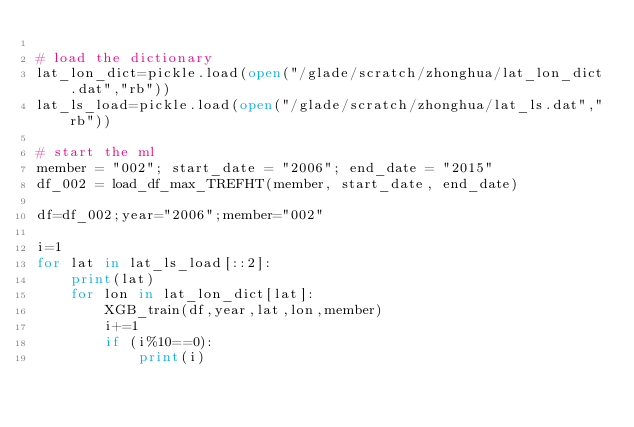<code> <loc_0><loc_0><loc_500><loc_500><_Python_>
# load the dictionary
lat_lon_dict=pickle.load(open("/glade/scratch/zhonghua/lat_lon_dict.dat","rb"))
lat_ls_load=pickle.load(open("/glade/scratch/zhonghua/lat_ls.dat","rb"))

# start the ml
member = "002"; start_date = "2006"; end_date = "2015"
df_002 = load_df_max_TREFHT(member, start_date, end_date)

df=df_002;year="2006";member="002"

i=1
for lat in lat_ls_load[::2]:
    print(lat)
    for lon in lat_lon_dict[lat]:
        XGB_train(df,year,lat,lon,member)
        i+=1
        if (i%10==0):
            print(i)</code> 